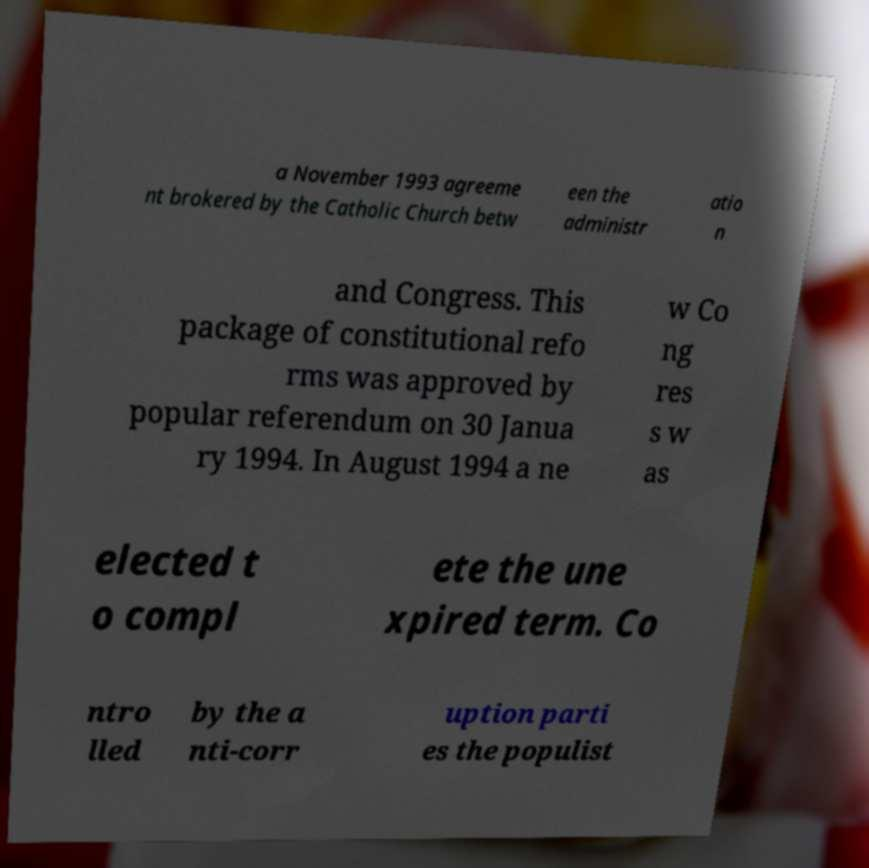For documentation purposes, I need the text within this image transcribed. Could you provide that? a November 1993 agreeme nt brokered by the Catholic Church betw een the administr atio n and Congress. This package of constitutional refo rms was approved by popular referendum on 30 Janua ry 1994. In August 1994 a ne w Co ng res s w as elected t o compl ete the une xpired term. Co ntro lled by the a nti-corr uption parti es the populist 